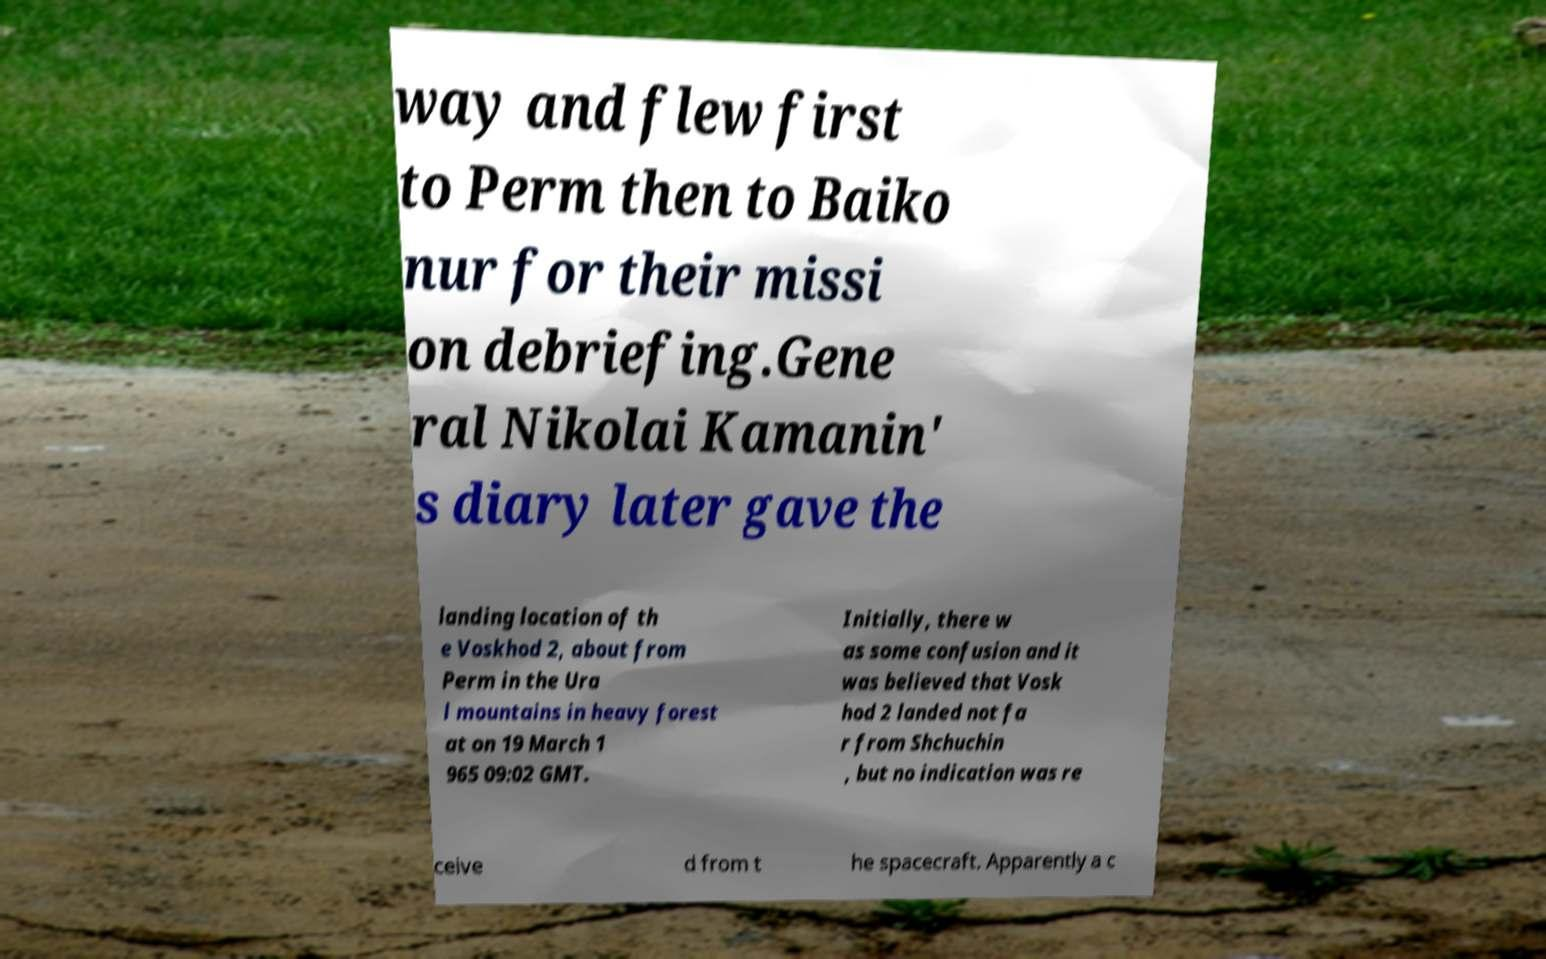Can you accurately transcribe the text from the provided image for me? way and flew first to Perm then to Baiko nur for their missi on debriefing.Gene ral Nikolai Kamanin' s diary later gave the landing location of th e Voskhod 2, about from Perm in the Ura l mountains in heavy forest at on 19 March 1 965 09:02 GMT. Initially, there w as some confusion and it was believed that Vosk hod 2 landed not fa r from Shchuchin , but no indication was re ceive d from t he spacecraft. Apparently a c 